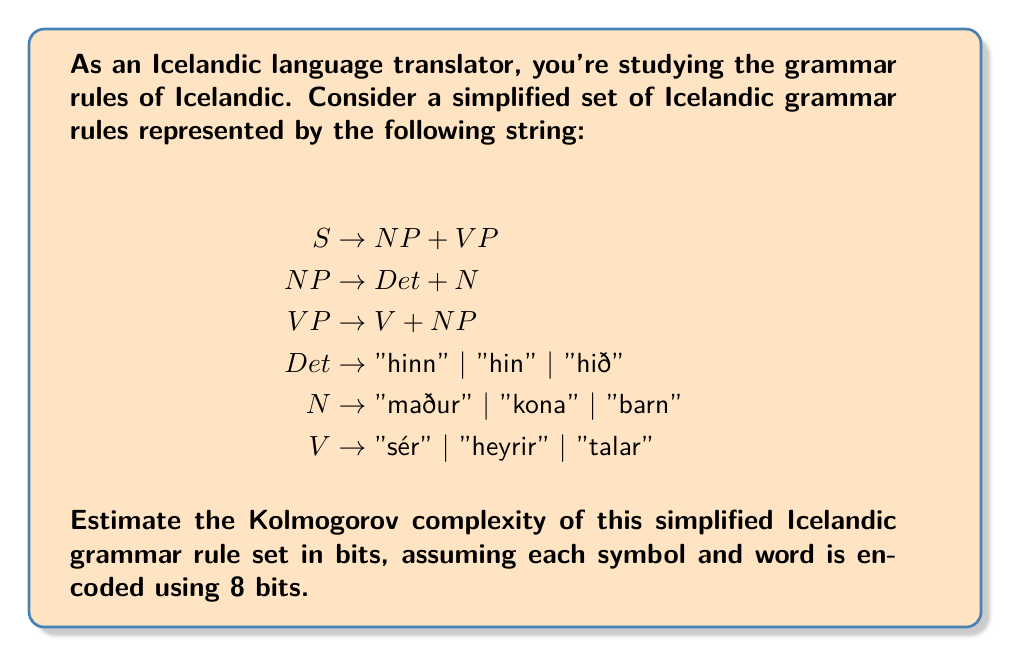Show me your answer to this math problem. To estimate the Kolmogorov complexity of the simplified Icelandic grammar rules, we need to determine the shortest possible description of these rules. Let's break it down step by step:

1. Count the unique symbols:
   - Non-terminal symbols: S, NP, VP, Det, N, V (6 symbols)
   - Terminal symbols: "hinn", "hin", "hið", "maður", "kona", "barn", "sér", "heyrir", "talar" (9 words)
   - Other symbols: →, +, | (3 symbols)

2. Calculate the number of bits needed to represent each component:
   - Non-terminal symbols: 6 × 8 = 48 bits
   - Terminal symbols (words): 9 × 8 = 72 bits
   - Other symbols: 3 × 8 = 24 bits

3. Count the number of production rules:
   - There are 6 production rules in total

4. Estimate the bits needed to represent the structure:
   - Each rule requires about 2 bits to indicate its structure (e.g., A → B + C or A → B | C | D)
   - Total for rule structure: 6 × 2 = 12 bits

5. Sum up all the components:
   $$\text{Total bits} = 48 + 72 + 24 + 12 = 156 \text{ bits}$$

This estimate assumes a very basic encoding scheme. In practice, a more sophisticated compression algorithm might achieve a lower bit count, but this gives us a reasonable upper bound for the Kolmogorov complexity of the simplified Icelandic grammar rules.
Answer: 156 bits 